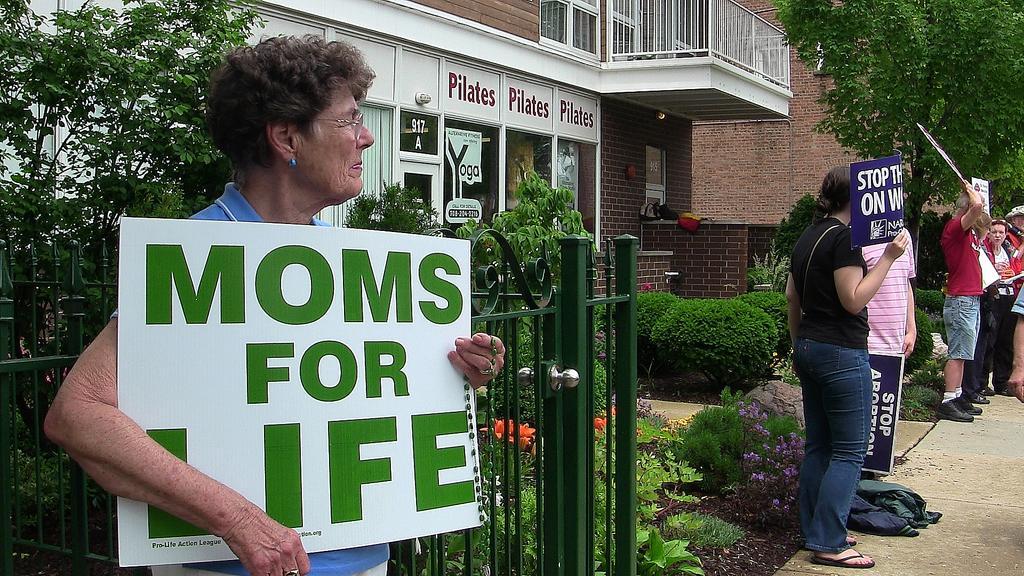Describe this image in one or two sentences. In this picture we can see men holding placards and standing on the footpath. On the left there are plants, flowers and railing. In the center of the picture there are plants, flowers and buildings. On the right there are trees and brick wall. 